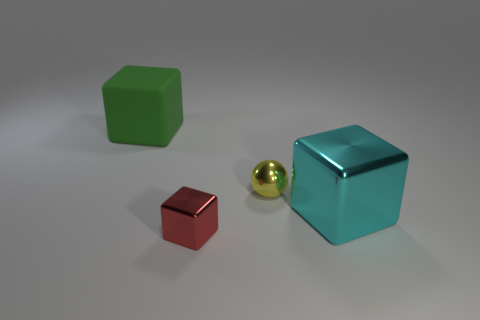Add 3 cubes. How many objects exist? 7 Subtract all cubes. How many objects are left? 1 Subtract 0 yellow cubes. How many objects are left? 4 Subtract all shiny blocks. Subtract all cyan metal objects. How many objects are left? 1 Add 2 red objects. How many red objects are left? 3 Add 1 large yellow cylinders. How many large yellow cylinders exist? 1 